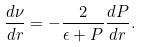Convert formula to latex. <formula><loc_0><loc_0><loc_500><loc_500>\frac { d \nu } { d r } = - \frac { 2 } { \epsilon + P } \frac { d P } { d r } .</formula> 